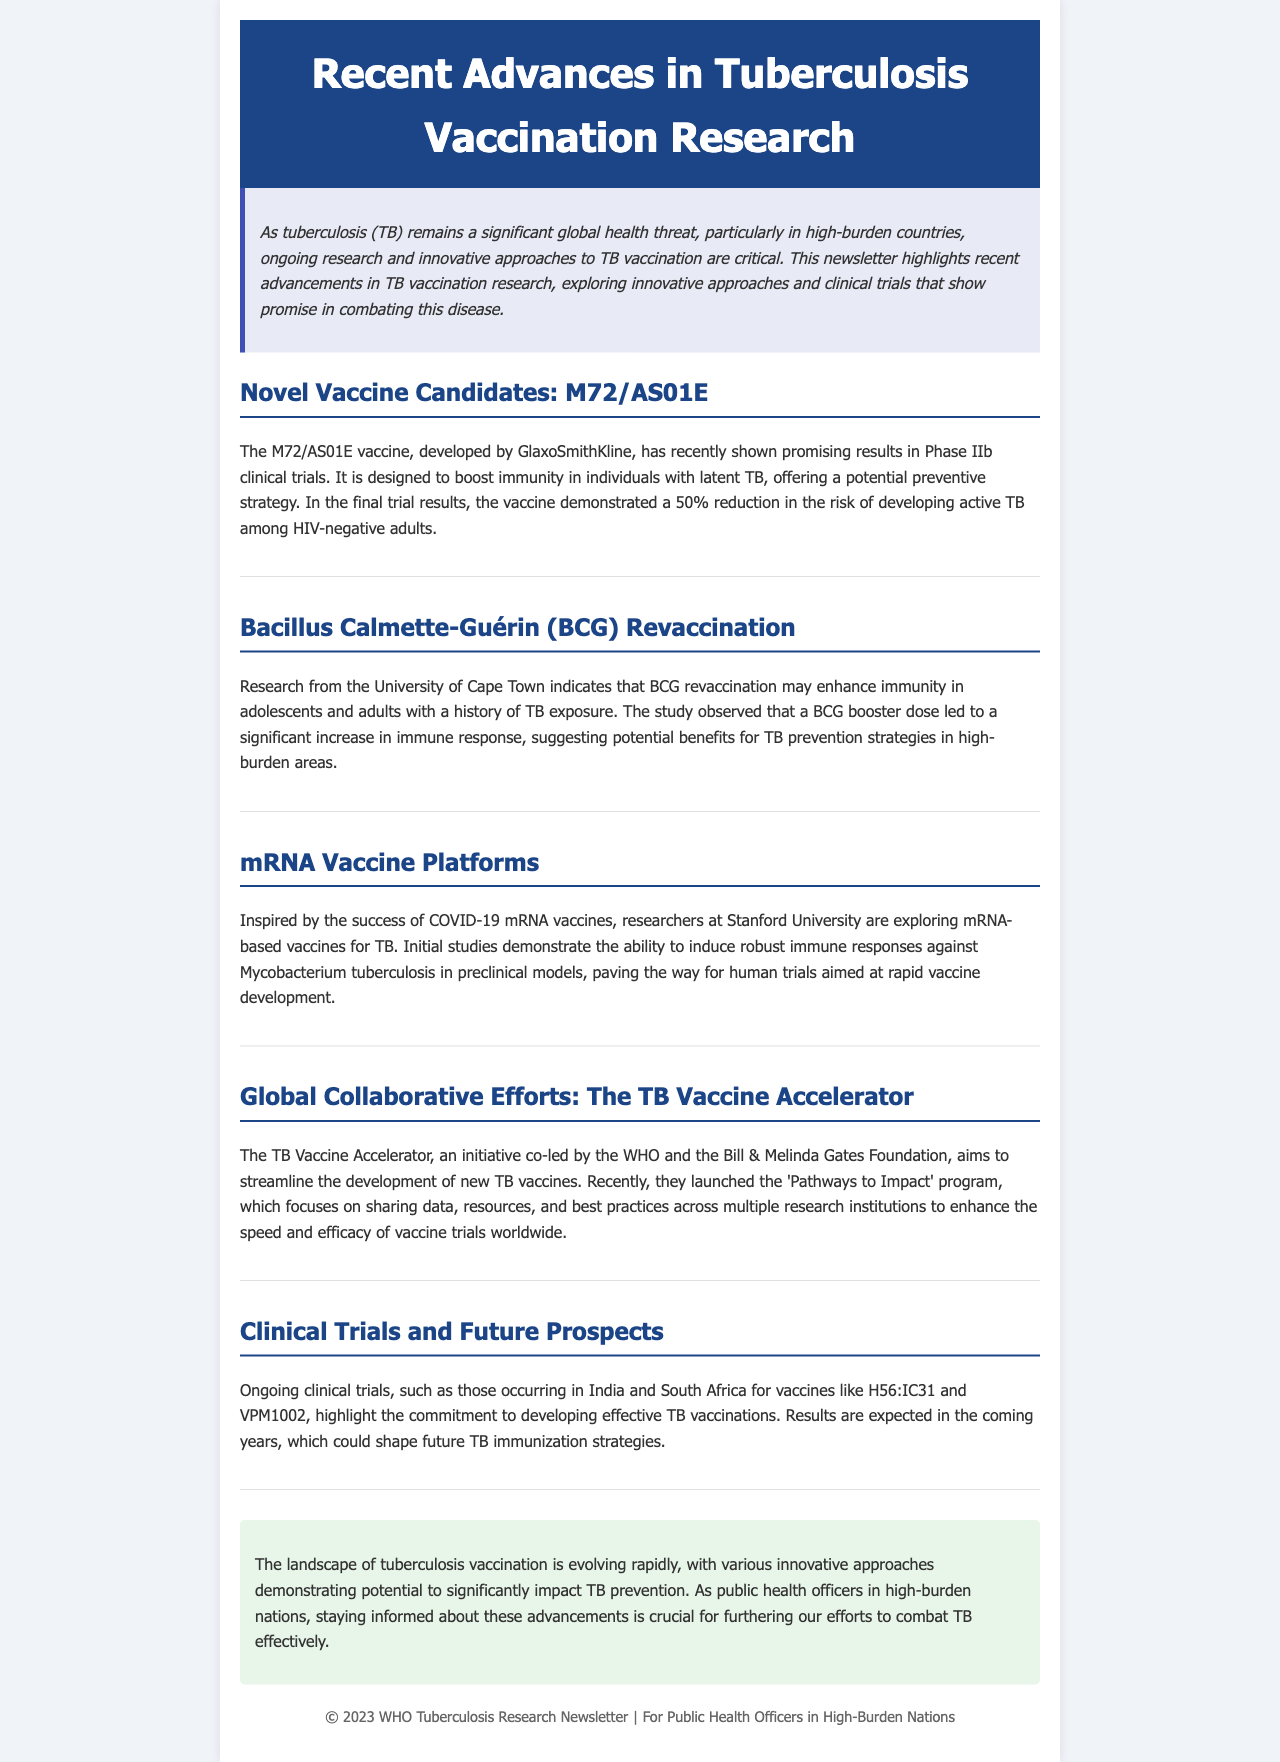What is the name of the vaccine developed by GlaxoSmithKline? The document mentions the M72/AS01E vaccine developed by GlaxoSmithKline.
Answer: M72/AS01E What percentage reduction in active TB risk was observed with the M72/AS01E vaccine? The M72/AS01E vaccine demonstrated a 50% reduction in the risk of developing active TB.
Answer: 50% Which university conducted research on BCG revaccination? The University of Cape Town conducted the research on BCG revaccination and its effects.
Answer: University of Cape Town What type of vaccine platforms are being explored by researchers at Stanford University? Researchers at Stanford University are exploring mRNA vaccine platforms for TB.
Answer: mRNA vaccine platforms What initiative is co-led by the WHO and the Bill & Melinda Gates Foundation? The initiative co-led by the WHO and the Bill & Melinda Gates Foundation is the TB Vaccine Accelerator.
Answer: TB Vaccine Accelerator What is the focus of the 'Pathways to Impact' program? The 'Pathways to Impact' program focuses on sharing data, resources, and best practices across research institutions.
Answer: Sharing data, resources, and best practices In which countries are ongoing clinical trials for vaccines like H56:IC31 and VPM1002 taking place? The ongoing clinical trials are taking place in India and South Africa.
Answer: India and South Africa What is the main theme of the newsletter? The main theme of the newsletter is recent advancements in tuberculosis vaccination research.
Answer: Recent advancements in tuberculosis vaccination research How are public health officers encouraged to respond to the evolving landscape of TB vaccination? Public health officers are encouraged to stay informed about advancements in TB vaccination to combat TB effectively.
Answer: Stay informed about advancements in TB vaccination 